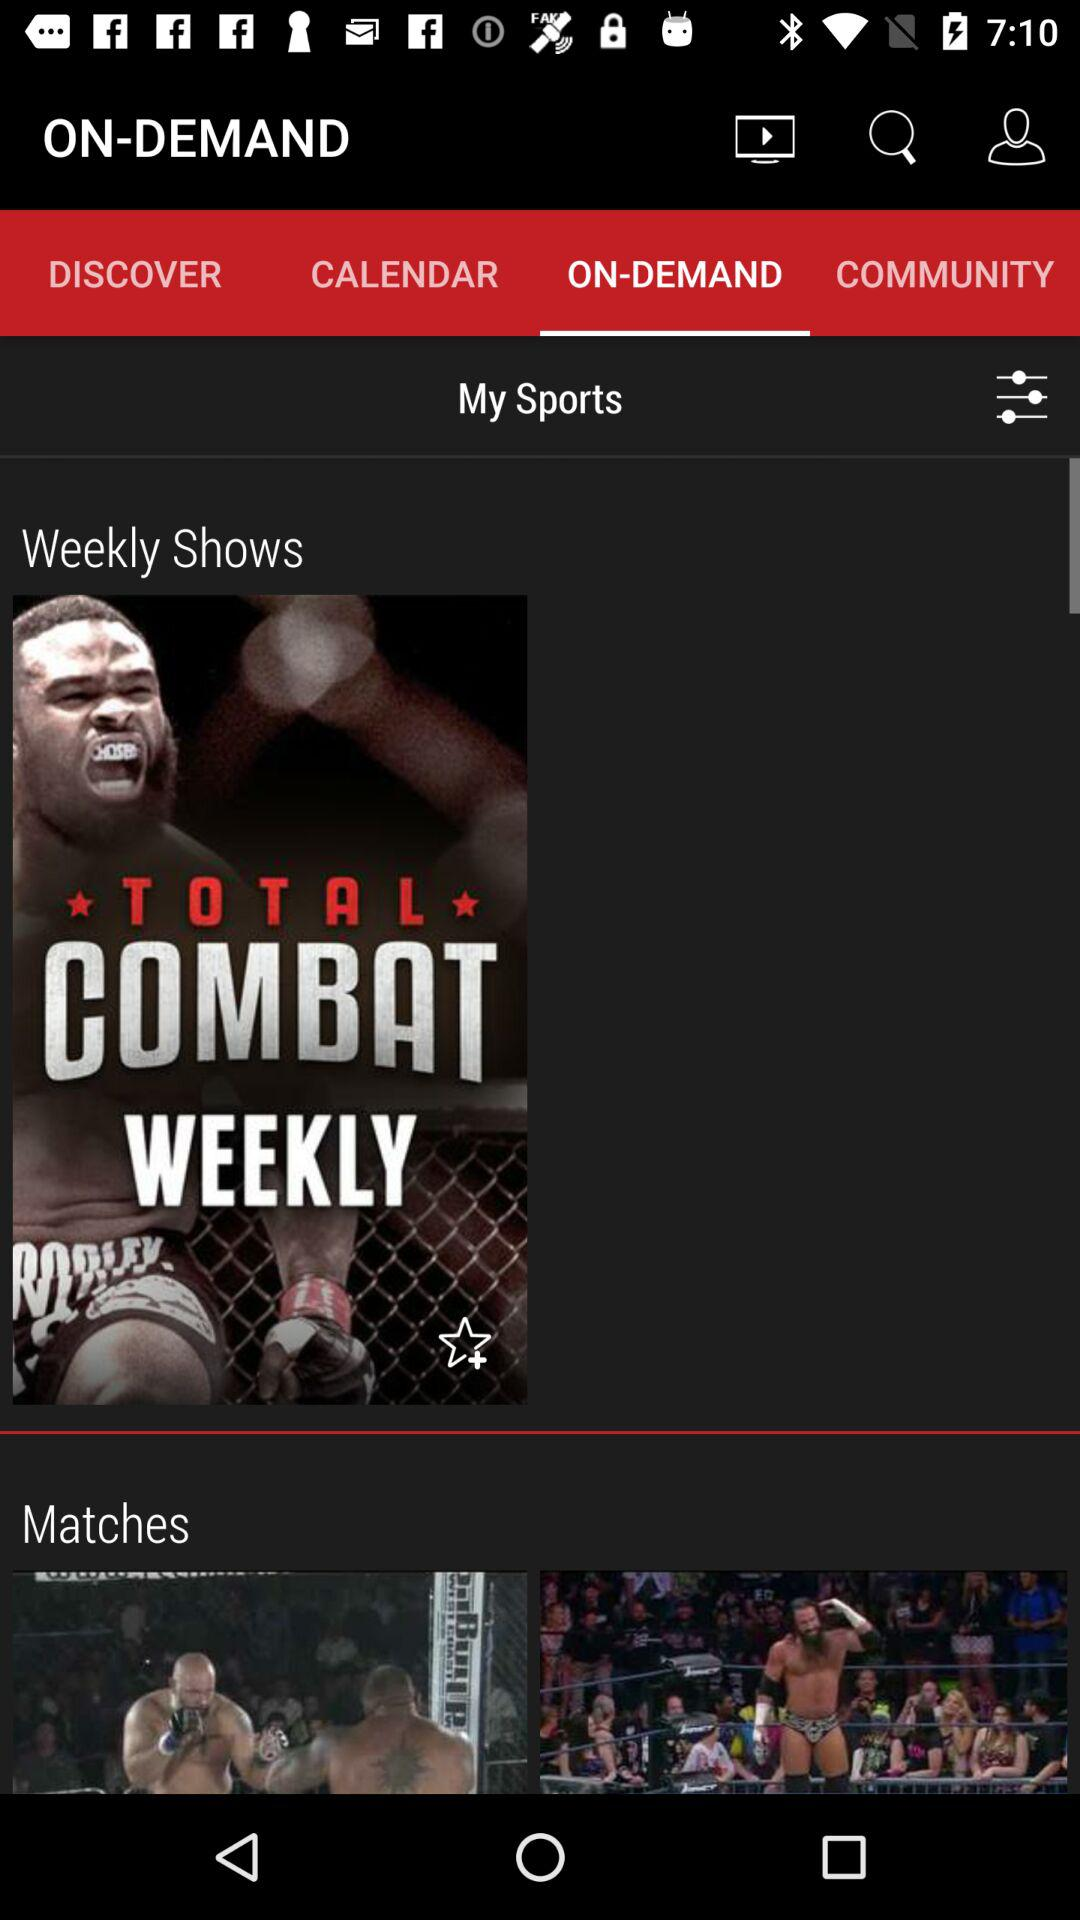Which tab is selected? The selected tab is "ON-DEMAND". 